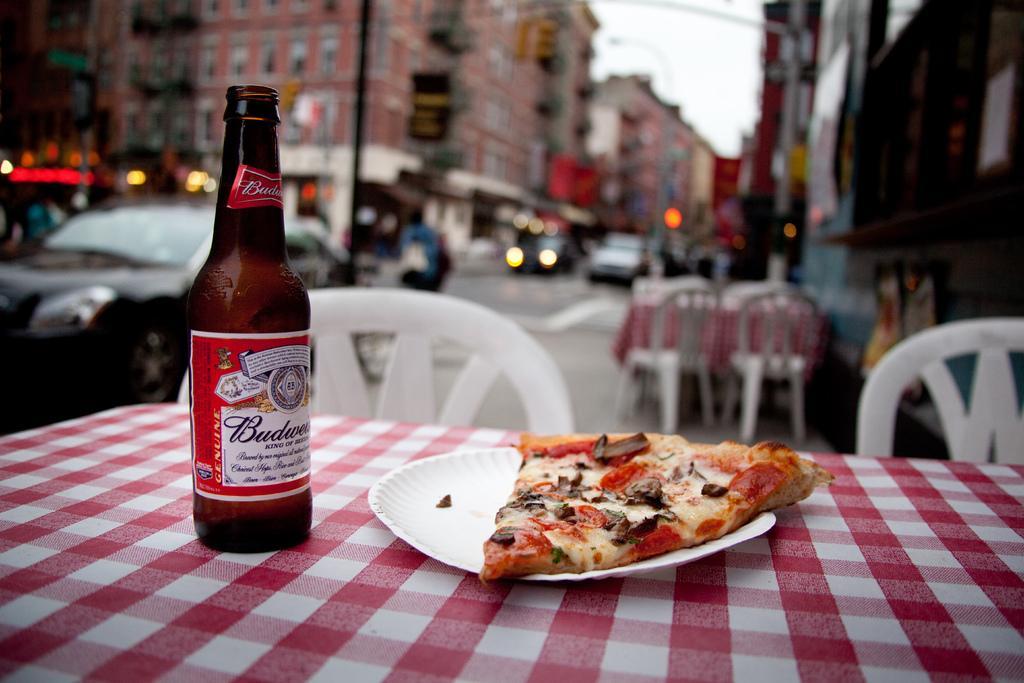How would you summarize this image in a sentence or two? This is the picture of a city. In the foreground there is a bottle and plate on the table and there is a pizza on the plate. At the back there are tables and chairs and there are vehicles on the road and there are buildings and street lights. At the top there is sky. At the bottom there is a road. 